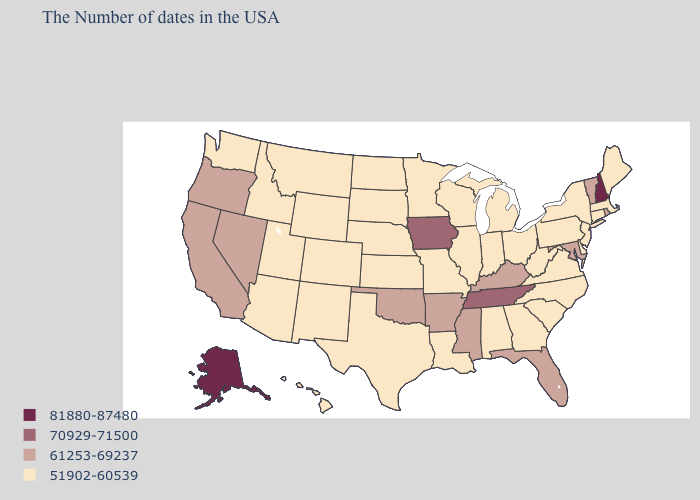How many symbols are there in the legend?
Concise answer only. 4. What is the lowest value in states that border Mississippi?
Keep it brief. 51902-60539. Name the states that have a value in the range 61253-69237?
Be succinct. Rhode Island, Vermont, Maryland, Florida, Kentucky, Mississippi, Arkansas, Oklahoma, Nevada, California, Oregon. Among the states that border Nebraska , does Missouri have the lowest value?
Write a very short answer. Yes. Does the map have missing data?
Be succinct. No. What is the value of Texas?
Be succinct. 51902-60539. What is the value of Pennsylvania?
Short answer required. 51902-60539. Which states have the lowest value in the West?
Quick response, please. Wyoming, Colorado, New Mexico, Utah, Montana, Arizona, Idaho, Washington, Hawaii. Does Alaska have the highest value in the USA?
Be succinct. Yes. What is the value of New Jersey?
Answer briefly. 51902-60539. Does New Jersey have a higher value than West Virginia?
Answer briefly. No. What is the value of Hawaii?
Give a very brief answer. 51902-60539. What is the highest value in states that border Alabama?
Give a very brief answer. 70929-71500. Does the map have missing data?
Keep it brief. No. Does Maryland have the same value as Colorado?
Concise answer only. No. 